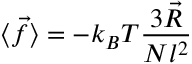Convert formula to latex. <formula><loc_0><loc_0><loc_500><loc_500>\langle { \vec { f } } \rangle = - k _ { B } T { \frac { 3 { \vec { R } } } { N l ^ { 2 } } }</formula> 